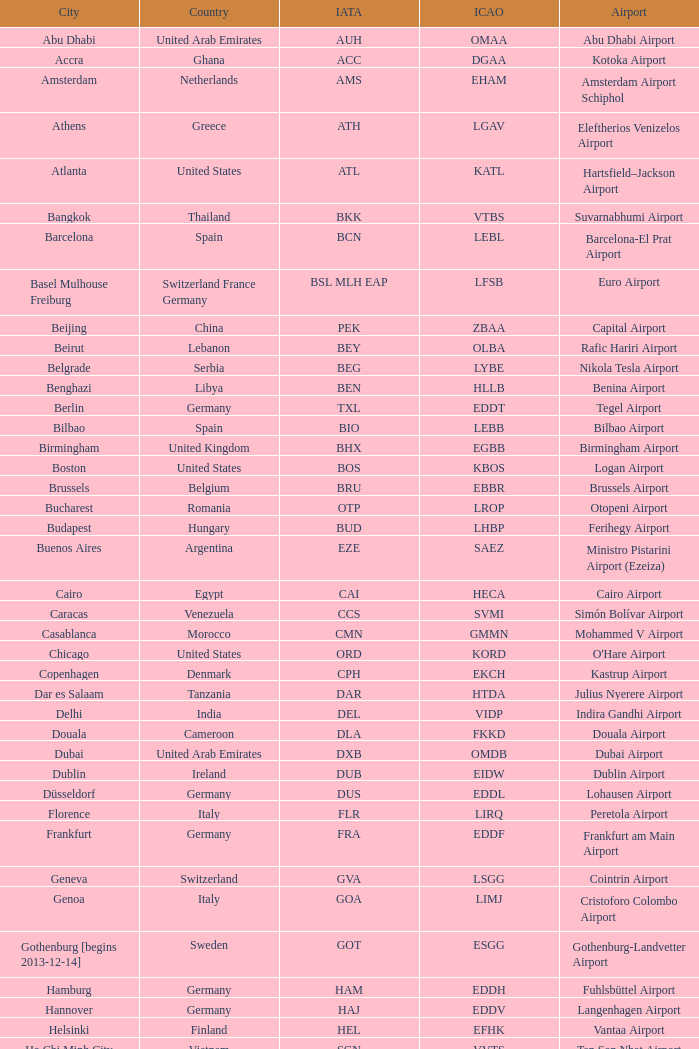Can you provide the iata for the uk's ringway airport? MAN. 